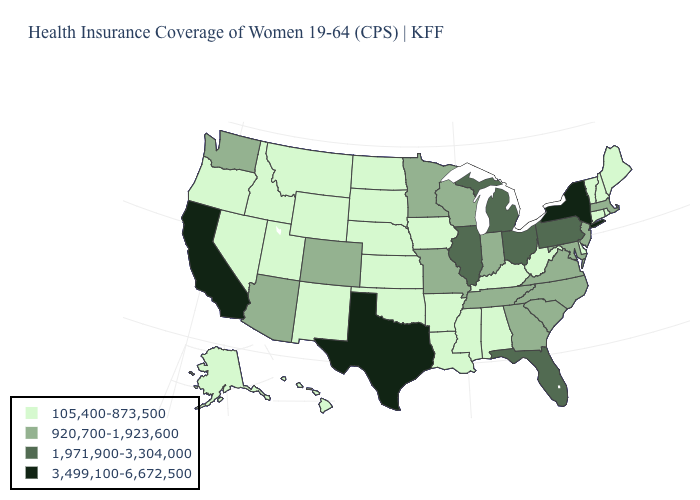What is the value of Rhode Island?
Keep it brief. 105,400-873,500. What is the value of Maryland?
Be succinct. 920,700-1,923,600. Name the states that have a value in the range 3,499,100-6,672,500?
Short answer required. California, New York, Texas. Does the first symbol in the legend represent the smallest category?
Short answer required. Yes. Which states have the lowest value in the MidWest?
Be succinct. Iowa, Kansas, Nebraska, North Dakota, South Dakota. Does the first symbol in the legend represent the smallest category?
Concise answer only. Yes. Name the states that have a value in the range 1,971,900-3,304,000?
Concise answer only. Florida, Illinois, Michigan, Ohio, Pennsylvania. Which states hav the highest value in the Northeast?
Keep it brief. New York. What is the value of Indiana?
Short answer required. 920,700-1,923,600. What is the value of Nebraska?
Concise answer only. 105,400-873,500. Name the states that have a value in the range 1,971,900-3,304,000?
Write a very short answer. Florida, Illinois, Michigan, Ohio, Pennsylvania. Does the map have missing data?
Give a very brief answer. No. What is the value of Oregon?
Answer briefly. 105,400-873,500. What is the value of Georgia?
Quick response, please. 920,700-1,923,600. What is the highest value in the West ?
Concise answer only. 3,499,100-6,672,500. 